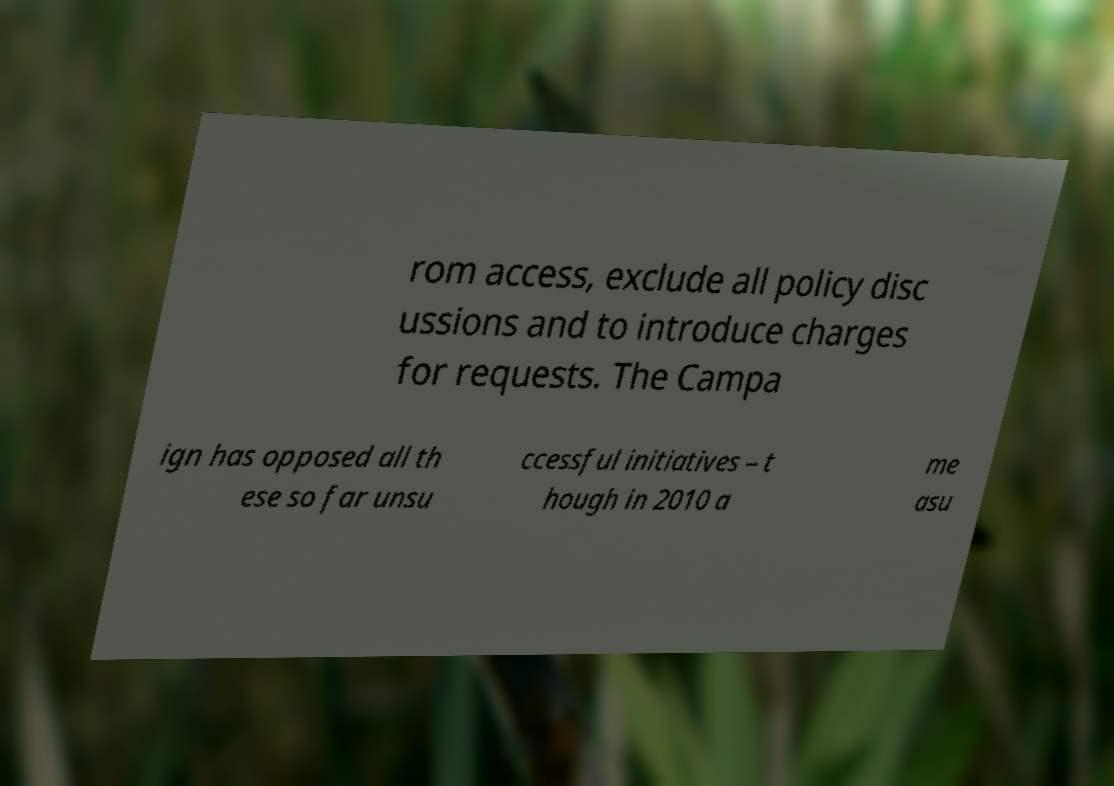Could you assist in decoding the text presented in this image and type it out clearly? rom access, exclude all policy disc ussions and to introduce charges for requests. The Campa ign has opposed all th ese so far unsu ccessful initiatives – t hough in 2010 a me asu 